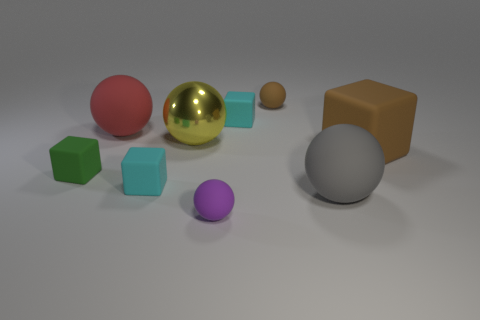There is a small rubber ball behind the large metal sphere; does it have the same color as the big cube?
Offer a very short reply. Yes. There is a tiny object that is the same color as the large matte block; what is its material?
Your response must be concise. Rubber. Are there any tiny objects of the same color as the big rubber cube?
Keep it short and to the point. Yes. Are there any blue spheres that have the same material as the red thing?
Your answer should be compact. No. There is a tiny cyan block that is to the right of the object that is in front of the large gray matte sphere; are there any large gray matte spheres in front of it?
Offer a very short reply. Yes. What number of other things are there of the same shape as the big yellow metal object?
Offer a very short reply. 4. There is a rubber sphere behind the red rubber sphere behind the cyan cube that is in front of the tiny green matte thing; what color is it?
Keep it short and to the point. Brown. How many large gray rubber things are there?
Your response must be concise. 1. How many small objects are either yellow metal objects or matte blocks?
Make the answer very short. 3. There is a red matte object that is the same size as the metal sphere; what is its shape?
Provide a succinct answer. Sphere. 